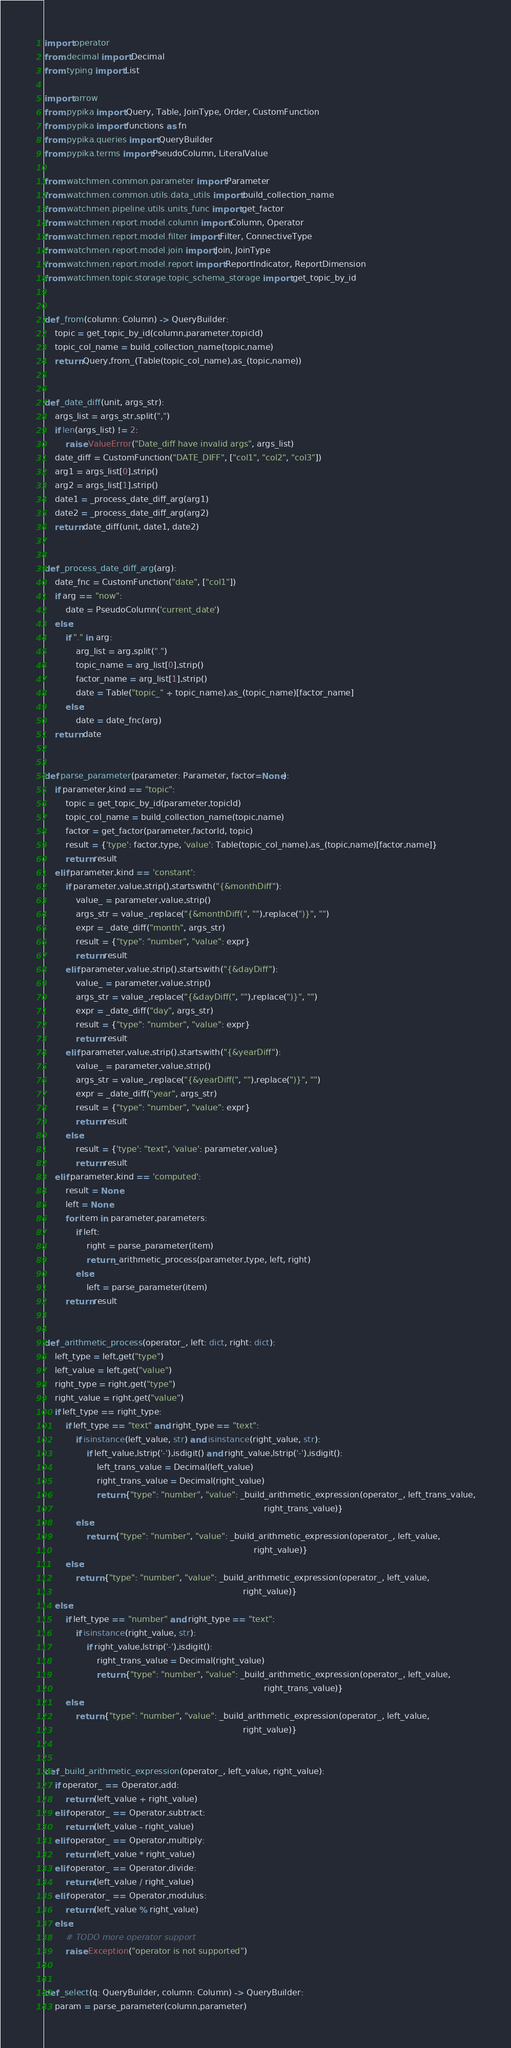<code> <loc_0><loc_0><loc_500><loc_500><_Python_>import operator
from decimal import Decimal
from typing import List

import arrow
from pypika import Query, Table, JoinType, Order, CustomFunction
from pypika import functions as fn
from pypika.queries import QueryBuilder
from pypika.terms import PseudoColumn, LiteralValue

from watchmen.common.parameter import Parameter
from watchmen.common.utils.data_utils import build_collection_name
from watchmen.pipeline.utils.units_func import get_factor
from watchmen.report.model.column import Column, Operator
from watchmen.report.model.filter import Filter, ConnectiveType
from watchmen.report.model.join import Join, JoinType
from watchmen.report.model.report import ReportIndicator, ReportDimension
from watchmen.topic.storage.topic_schema_storage import get_topic_by_id


def _from(column: Column) -> QueryBuilder:
    topic = get_topic_by_id(column.parameter.topicId)
    topic_col_name = build_collection_name(topic.name)
    return Query.from_(Table(topic_col_name).as_(topic.name))


def _date_diff(unit, args_str):
    args_list = args_str.split(",")
    if len(args_list) != 2:
        raise ValueError("Date_diff have invalid args", args_list)
    date_diff = CustomFunction("DATE_DIFF", ["col1", "col2", "col3"])
    arg1 = args_list[0].strip()
    arg2 = args_list[1].strip()
    date1 = _process_date_diff_arg(arg1)
    date2 = _process_date_diff_arg(arg2)
    return date_diff(unit, date1, date2)


def _process_date_diff_arg(arg):
    date_fnc = CustomFunction("date", ["col1"])
    if arg == "now":
        date = PseudoColumn('current_date')
    else:
        if "." in arg:
            arg_list = arg.split(".")
            topic_name = arg_list[0].strip()
            factor_name = arg_list[1].strip()
            date = Table("topic_" + topic_name).as_(topic_name)[factor_name]
        else:
            date = date_fnc(arg)
    return date


def parse_parameter(parameter: Parameter, factor=None):
    if parameter.kind == "topic":
        topic = get_topic_by_id(parameter.topicId)
        topic_col_name = build_collection_name(topic.name)
        factor = get_factor(parameter.factorId, topic)
        result = {'type': factor.type, 'value': Table(topic_col_name).as_(topic.name)[factor.name]}
        return result
    elif parameter.kind == 'constant':
        if parameter.value.strip().startswith("{&monthDiff"):
            value_ = parameter.value.strip()
            args_str = value_.replace("{&monthDiff(", "").replace(")}", "")
            expr = _date_diff("month", args_str)
            result = {"type": "number", "value": expr}
            return result
        elif parameter.value.strip().startswith("{&dayDiff"):
            value_ = parameter.value.strip()
            args_str = value_.replace("{&dayDiff(", "").replace(")}", "")
            expr = _date_diff("day", args_str)
            result = {"type": "number", "value": expr}
            return result
        elif parameter.value.strip().startswith("{&yearDiff"):
            value_ = parameter.value.strip()
            args_str = value_.replace("{&yearDiff(", "").replace(")}", "")
            expr = _date_diff("year", args_str)
            result = {"type": "number", "value": expr}
            return result
        else:
            result = {'type': "text", 'value': parameter.value}
            return result
    elif parameter.kind == 'computed':
        result = None
        left = None
        for item in parameter.parameters:
            if left:
                right = parse_parameter(item)
                return _arithmetic_process(parameter.type, left, right)
            else:
                left = parse_parameter(item)
        return result


def _arithmetic_process(operator_, left: dict, right: dict):
    left_type = left.get("type")
    left_value = left.get("value")
    right_type = right.get("type")
    right_value = right.get("value")
    if left_type == right_type:
        if left_type == "text" and right_type == "text":
            if isinstance(left_value, str) and isinstance(right_value, str):
                if left_value.lstrip('-').isdigit() and right_value.lstrip('-').isdigit():
                    left_trans_value = Decimal(left_value)
                    right_trans_value = Decimal(right_value)
                    return {"type": "number", "value": _build_arithmetic_expression(operator_, left_trans_value,
                                                                                    right_trans_value)}
            else:
                return {"type": "number", "value": _build_arithmetic_expression(operator_, left_value,
                                                                                right_value)}
        else:
            return {"type": "number", "value": _build_arithmetic_expression(operator_, left_value,
                                                                            right_value)}
    else:
        if left_type == "number" and right_type == "text":
            if isinstance(right_value, str):
                if right_value.lstrip('-').isdigit():
                    right_trans_value = Decimal(right_value)
                    return {"type": "number", "value": _build_arithmetic_expression(operator_, left_value,
                                                                                    right_trans_value)}
        else:
            return {"type": "number", "value": _build_arithmetic_expression(operator_, left_value,
                                                                            right_value)}


def _build_arithmetic_expression(operator_, left_value, right_value):
    if operator_ == Operator.add:
        return (left_value + right_value)
    elif operator_ == Operator.subtract:
        return (left_value - right_value)
    elif operator_ == Operator.multiply:
        return (left_value * right_value)
    elif operator_ == Operator.divide:
        return (left_value / right_value)
    elif operator_ == Operator.modulus:
        return (left_value % right_value)
    else:
        # TODO more operator support
        raise Exception("operator is not supported")


def _select(q: QueryBuilder, column: Column) -> QueryBuilder:
    param = parse_parameter(column.parameter)</code> 